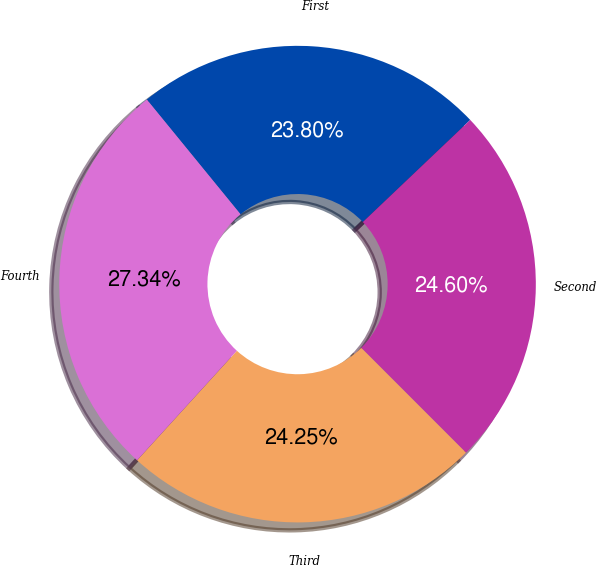Convert chart to OTSL. <chart><loc_0><loc_0><loc_500><loc_500><pie_chart><fcel>First<fcel>Second<fcel>Third<fcel>Fourth<nl><fcel>23.8%<fcel>24.6%<fcel>24.25%<fcel>27.34%<nl></chart> 